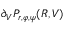<formula> <loc_0><loc_0><loc_500><loc_500>\partial _ { V } P _ { r , \varphi , \psi } ( R , V )</formula> 